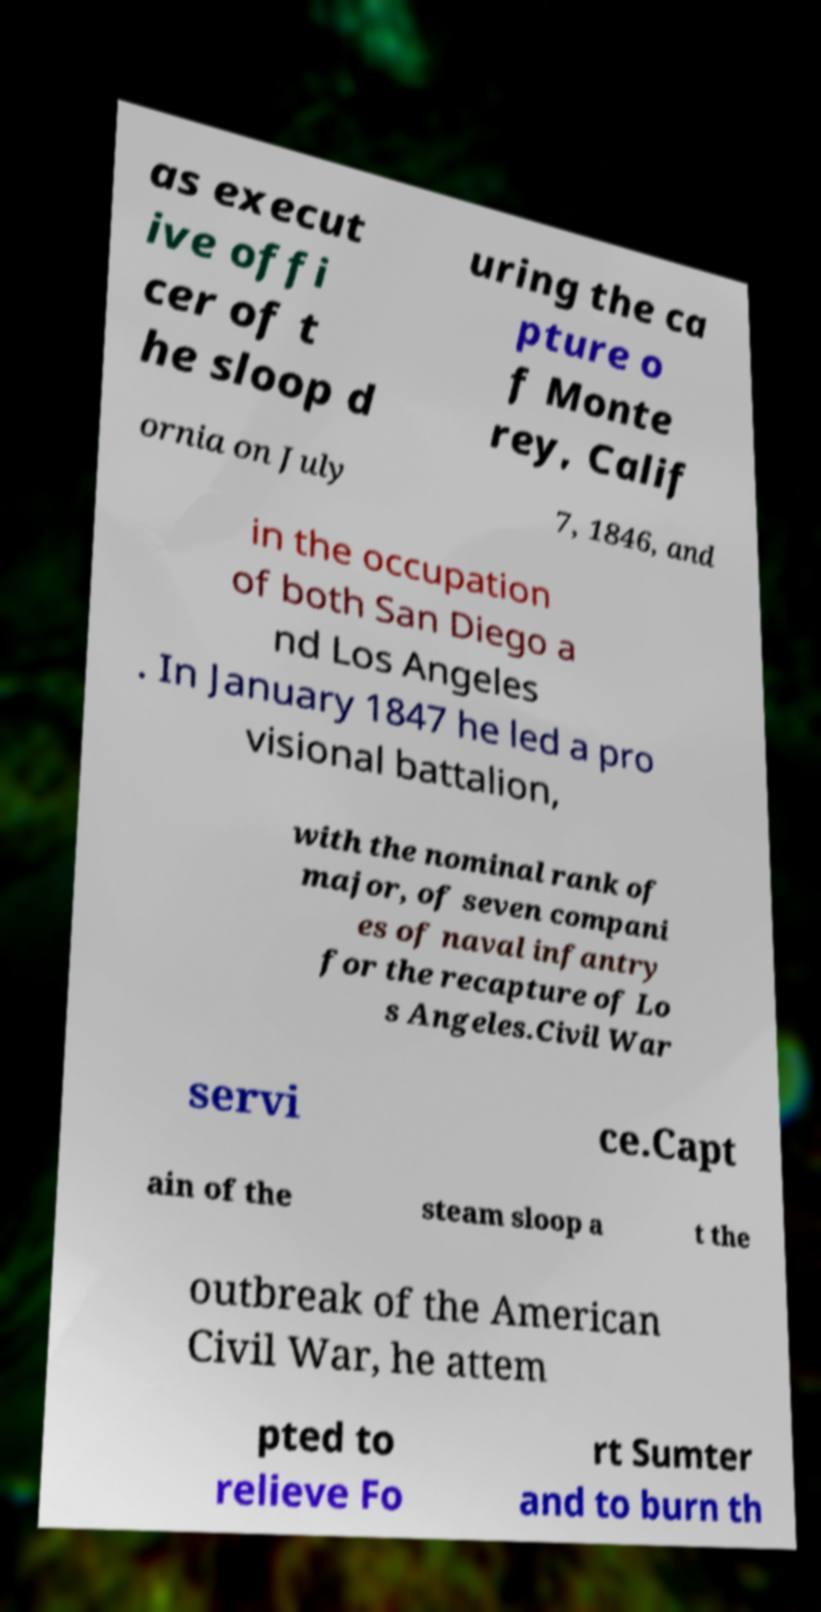Please identify and transcribe the text found in this image. as execut ive offi cer of t he sloop d uring the ca pture o f Monte rey, Calif ornia on July 7, 1846, and in the occupation of both San Diego a nd Los Angeles . In January 1847 he led a pro visional battalion, with the nominal rank of major, of seven compani es of naval infantry for the recapture of Lo s Angeles.Civil War servi ce.Capt ain of the steam sloop a t the outbreak of the American Civil War, he attem pted to relieve Fo rt Sumter and to burn th 